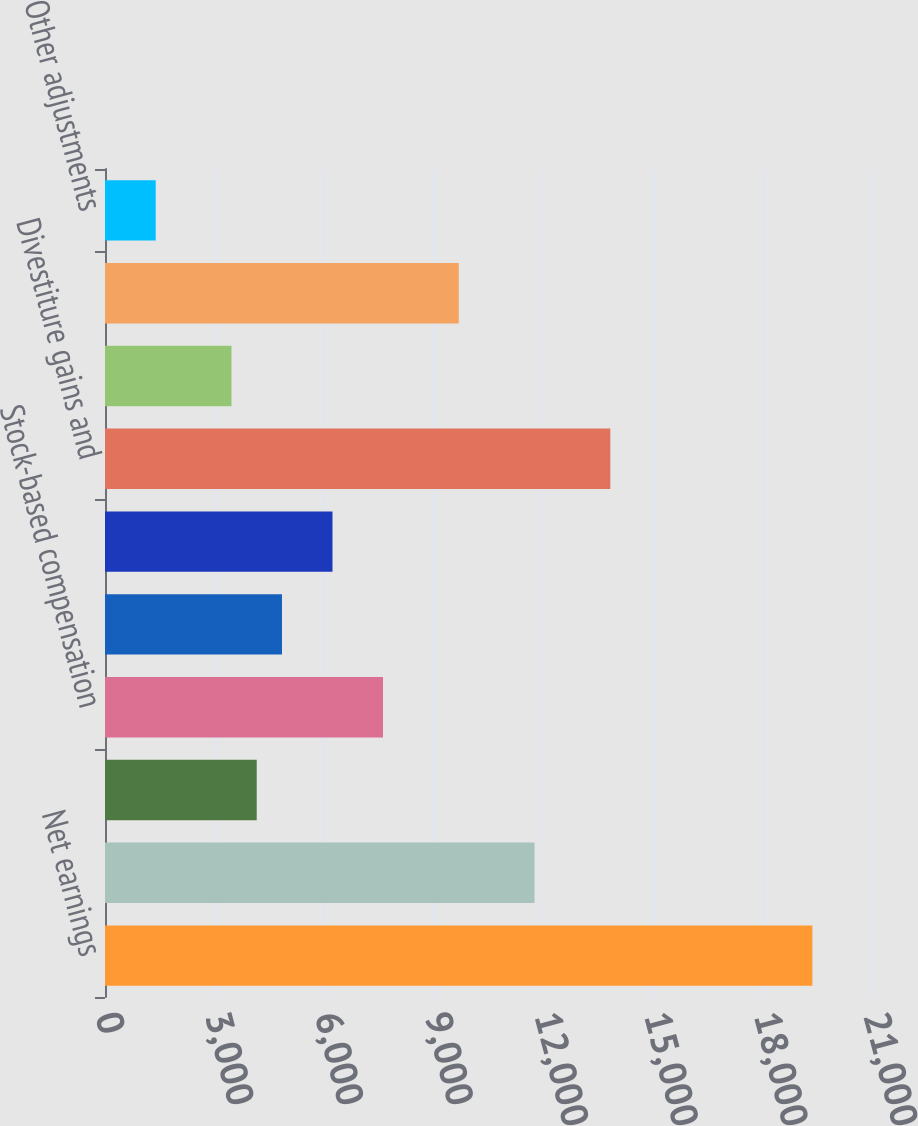Convert chart to OTSL. <chart><loc_0><loc_0><loc_500><loc_500><bar_chart><fcel>Net earnings<fcel>Depreciation and amortization<fcel>Deferred income taxes<fcel>Stock-based compensation<fcel>Impairment charges<fcel>Pension settlements and<fcel>Divestiture gains and<fcel>Asset acquisition charges<fcel>Loss/(gain) on equity<fcel>Other adjustments<nl><fcel>19341.8<fcel>11745.2<fcel>4148.6<fcel>7601.6<fcel>4839.2<fcel>6220.4<fcel>13817<fcel>3458<fcel>9673.4<fcel>1386.2<nl></chart> 